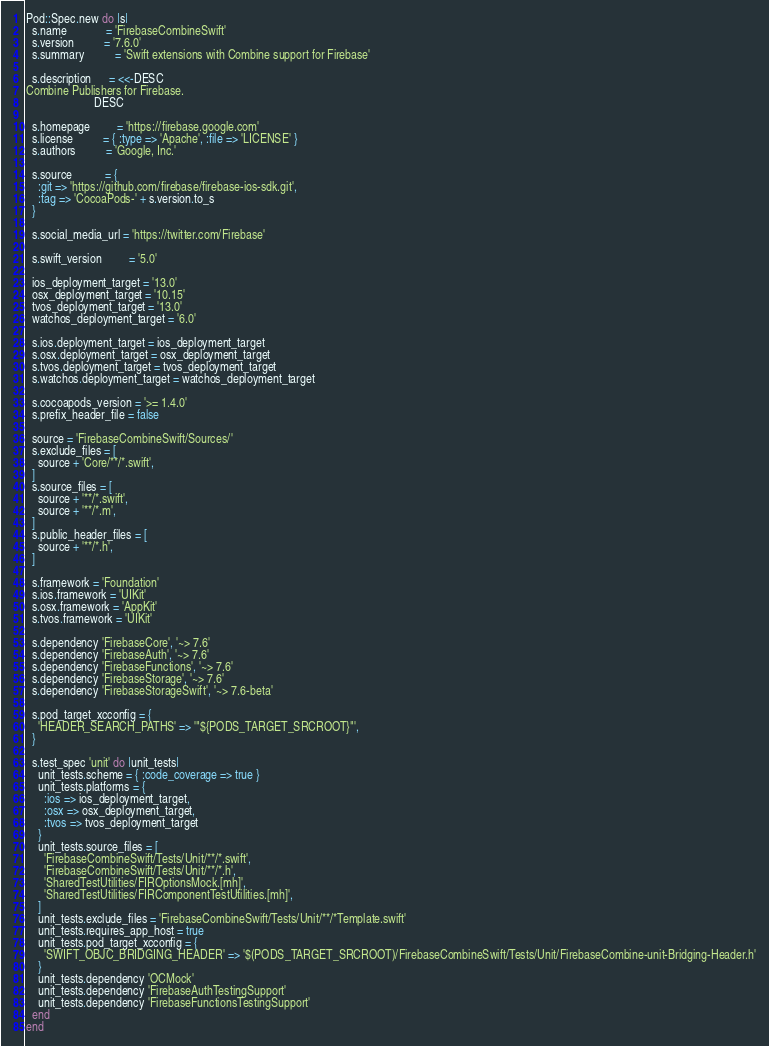<code> <loc_0><loc_0><loc_500><loc_500><_Ruby_>Pod::Spec.new do |s|
  s.name             = 'FirebaseCombineSwift'
  s.version          = '7.6.0'
  s.summary          = 'Swift extensions with Combine support for Firebase'

  s.description      = <<-DESC
Combine Publishers for Firebase.
                       DESC

  s.homepage         = 'https://firebase.google.com'
  s.license          = { :type => 'Apache', :file => 'LICENSE' }
  s.authors          = 'Google, Inc.'

  s.source           = {
    :git => 'https://github.com/firebase/firebase-ios-sdk.git',
    :tag => 'CocoaPods-' + s.version.to_s
  }

  s.social_media_url = 'https://twitter.com/Firebase'

  s.swift_version         = '5.0'

  ios_deployment_target = '13.0'
  osx_deployment_target = '10.15'
  tvos_deployment_target = '13.0'
  watchos_deployment_target = '6.0'

  s.ios.deployment_target = ios_deployment_target
  s.osx.deployment_target = osx_deployment_target
  s.tvos.deployment_target = tvos_deployment_target
  s.watchos.deployment_target = watchos_deployment_target

  s.cocoapods_version = '>= 1.4.0'
  s.prefix_header_file = false

  source = 'FirebaseCombineSwift/Sources/'
  s.exclude_files = [
    source + 'Core/**/*.swift',
  ]
  s.source_files = [
    source + '**/*.swift',
    source + '**/*.m',
  ]
  s.public_header_files = [
    source + '**/*.h',
  ]

  s.framework = 'Foundation'
  s.ios.framework = 'UIKit'
  s.osx.framework = 'AppKit'
  s.tvos.framework = 'UIKit'

  s.dependency 'FirebaseCore', '~> 7.6'
  s.dependency 'FirebaseAuth', '~> 7.6'
  s.dependency 'FirebaseFunctions', '~> 7.6'
  s.dependency 'FirebaseStorage', '~> 7.6'
  s.dependency 'FirebaseStorageSwift', '~> 7.6-beta'

  s.pod_target_xcconfig = {
    'HEADER_SEARCH_PATHS' => '"${PODS_TARGET_SRCROOT}"',
  }

  s.test_spec 'unit' do |unit_tests|
    unit_tests.scheme = { :code_coverage => true }
    unit_tests.platforms = {
      :ios => ios_deployment_target,
      :osx => osx_deployment_target,
      :tvos => tvos_deployment_target
    }
    unit_tests.source_files = [
      'FirebaseCombineSwift/Tests/Unit/**/*.swift',
      'FirebaseCombineSwift/Tests/Unit/**/*.h',
      'SharedTestUtilities/FIROptionsMock.[mh]',
      'SharedTestUtilities/FIRComponentTestUtilities.[mh]',
    ]
    unit_tests.exclude_files = 'FirebaseCombineSwift/Tests/Unit/**/*Template.swift'
    unit_tests.requires_app_host = true
    unit_tests.pod_target_xcconfig = {
      'SWIFT_OBJC_BRIDGING_HEADER' => '$(PODS_TARGET_SRCROOT)/FirebaseCombineSwift/Tests/Unit/FirebaseCombine-unit-Bridging-Header.h'
    }
    unit_tests.dependency 'OCMock'
    unit_tests.dependency 'FirebaseAuthTestingSupport'
    unit_tests.dependency 'FirebaseFunctionsTestingSupport'
  end
end
</code> 